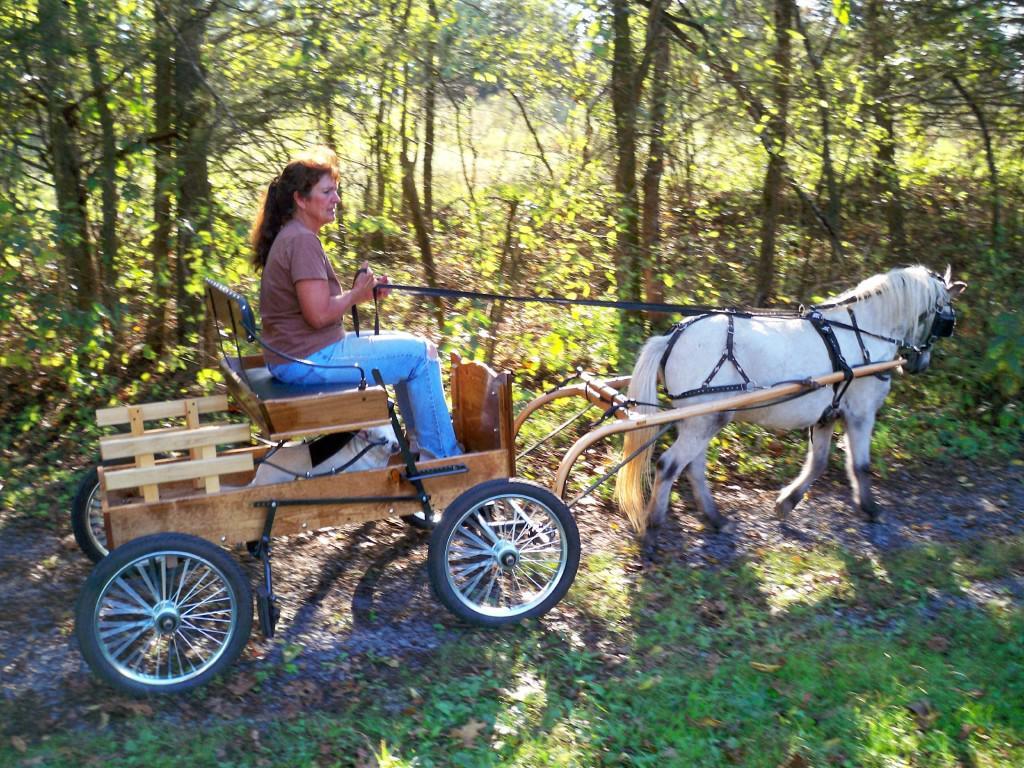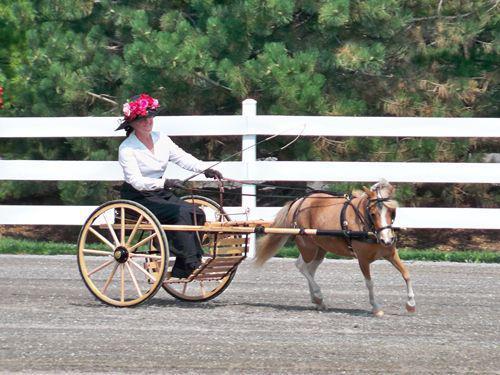The first image is the image on the left, the second image is the image on the right. Given the left and right images, does the statement "There are more than two people being pulled by a horse." hold true? Answer yes or no. No. The first image is the image on the left, the second image is the image on the right. For the images displayed, is the sentence "Each image depicts one person sitting in a cart pulled by a single pony or horse." factually correct? Answer yes or no. Yes. 